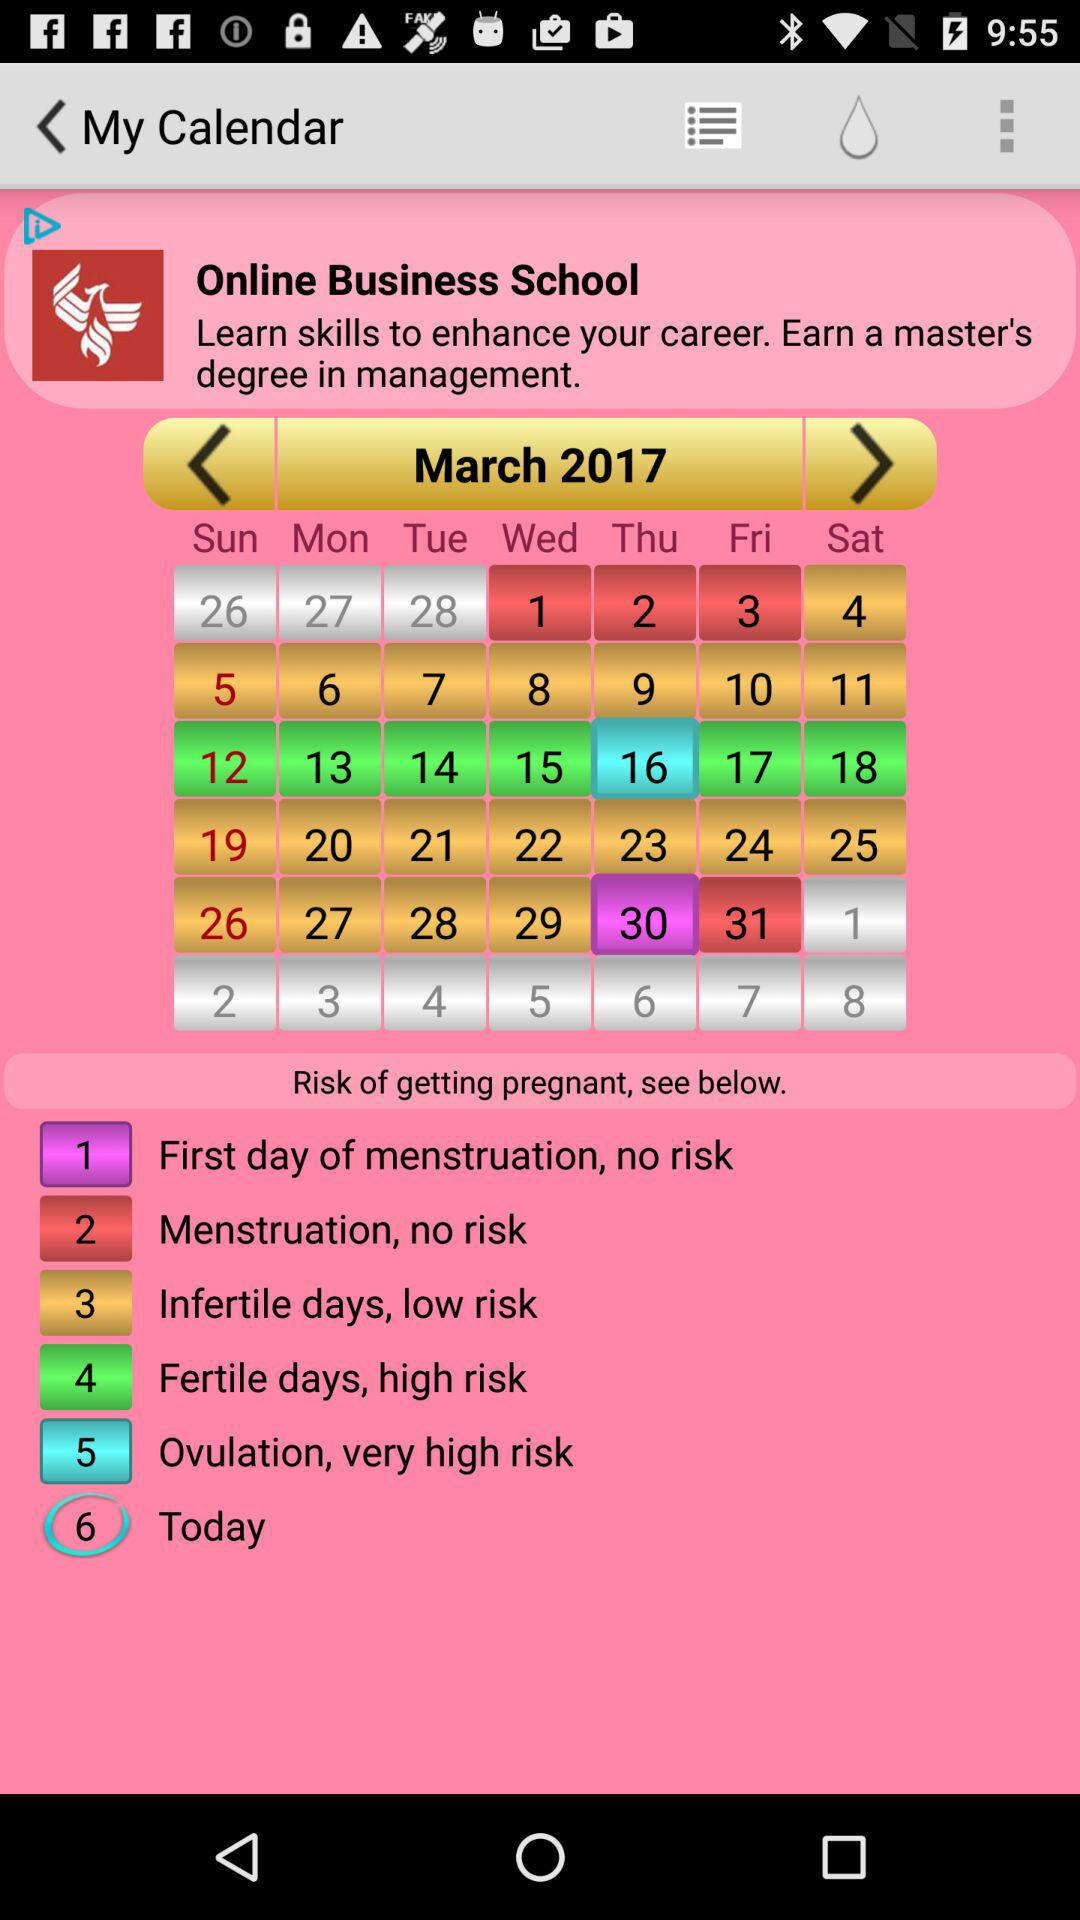Which ovulation date has a high risk? The ovulation date that has a high risk is Thursday, March 16, 2017. 